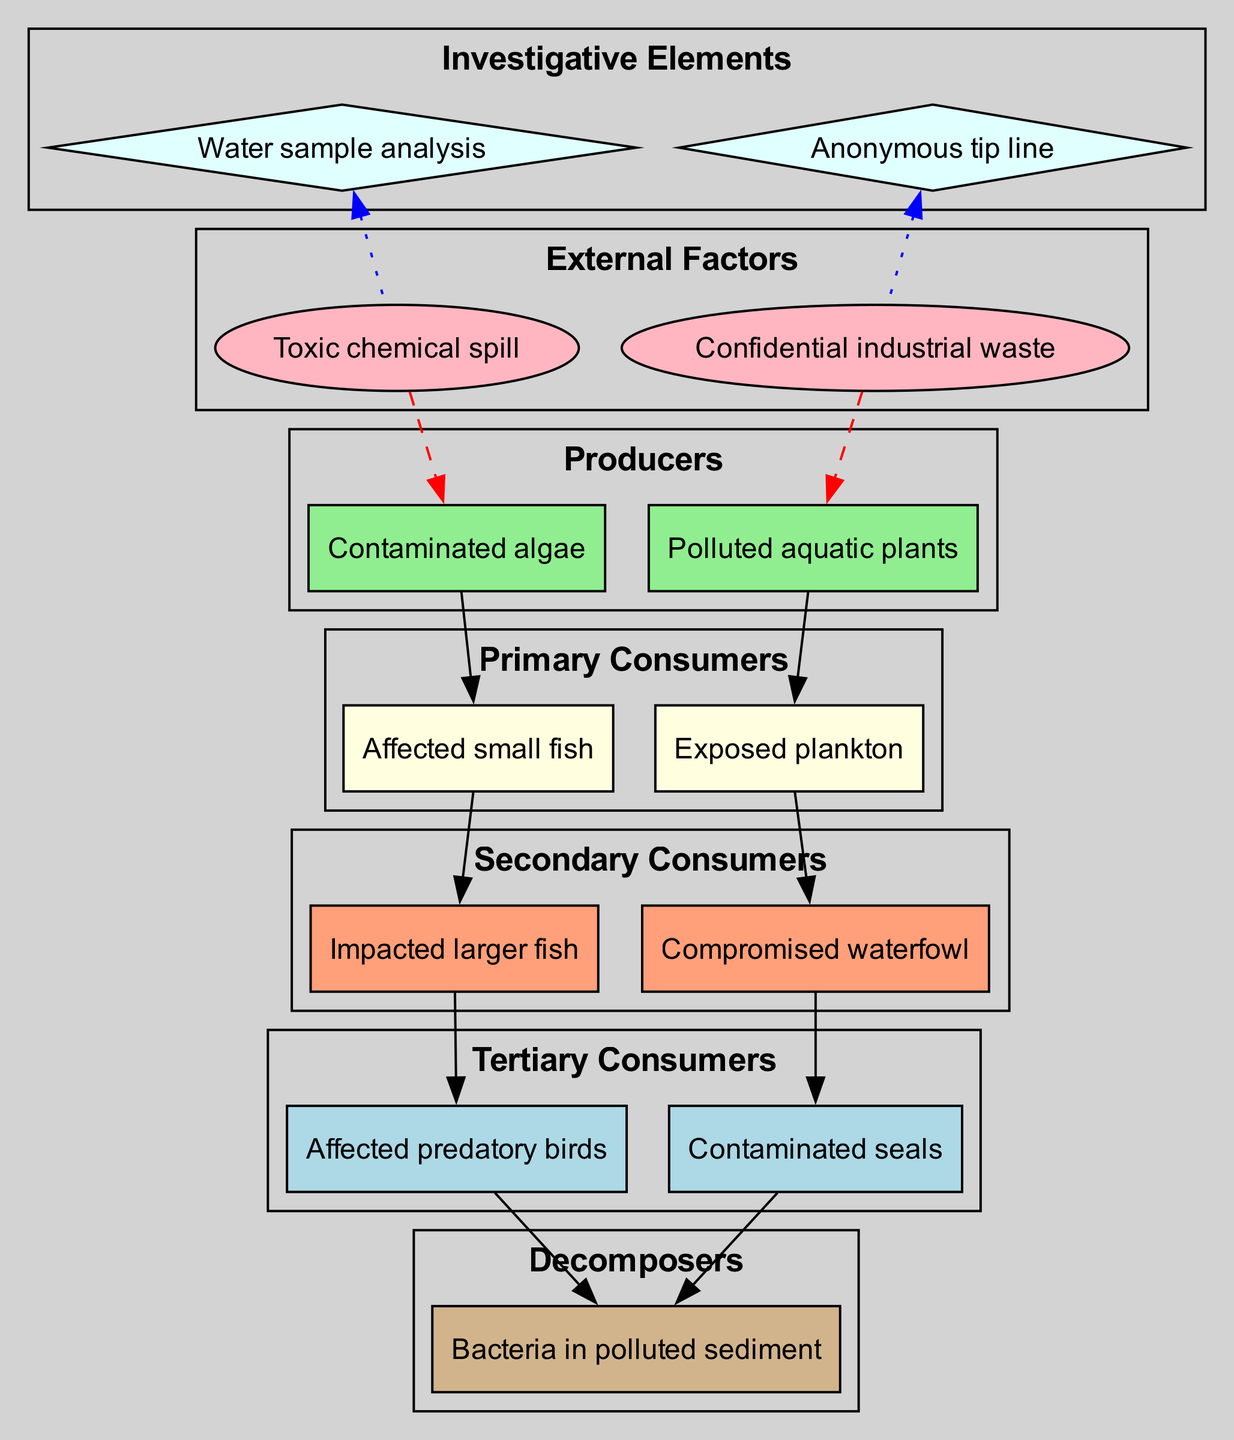What are the producers in this food chain? The producers are represented in the first cluster of the diagram and consist of the contaminated algae and polluted aquatic plants. These are the organisms that can produce energy for the rest of the food chain.
Answer: Contaminated algae, polluted aquatic plants How many primary consumers are there? Counting the nodes in the primary consumers cluster of the diagram, there are two nodes listed: affected small fish and exposed plankton. This indicates that there are two primary consumers present.
Answer: 2 Which secondary consumer is impacted by the affected small fish? The flow of the diagram shows that the affected small fish as a primary consumer leads to the impacted larger fish as a secondary consumer. Thus, the impacted larger fish is the one affected by the primary consumer.
Answer: Impacted larger fish What is the role of bacteria in polluted sediment? In the food chain diagram, bacteria in polluted sediment are categorized as decomposers. Their role is to break down the organic matter and recycle nutrients back into the ecosystem, enhancing the soil and sediment fertility.
Answer: Decomposers How do toxic external factors influence producers? The toxic external factors, such as the toxic chemical spill and confidential industrial waste, have directed edges leading to the producers. This implies that these factors negatively affect the health and efficiency of the producers in this ecosystem.
Answer: Negative influence What type of edge connects investigative elements to external factors? The edges connecting the investigative elements, such as water sample analysis and anonymous tip line, to the external factors are styled as dotted lines, indicating a supportive or non-directive relationship, rather than a direct influence.
Answer: Dotted edges Which tertiary consumer is associated with compromised waterfowl? Analyzing the flow of the diagram, the compromised waterfowl as a secondary consumer connects to affected predatory birds as a tertiary consumer. Hence, the tertiary consumer associated with compromised waterfowl is the affected predatory birds.
Answer: Affected predatory birds 